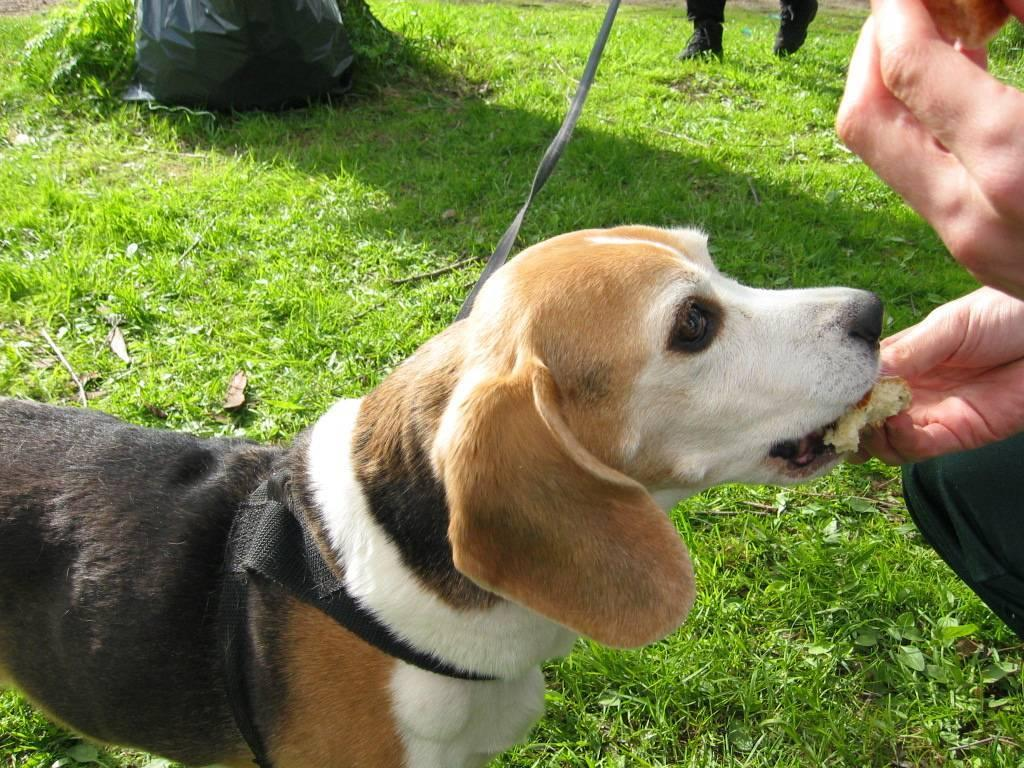How many people are in the image? There are two persons in the image. What is the dog doing in the image? The dog is being fed food by one of the persons. What type of surface is visible in the image? There is grass in the image. What color is the cover in the background of the image? The cover in the background of the image is black. What type of paper is the dog using to write its name in the image? There is no paper or writing activity involving the dog in the image. What substance is the elbow made of in the image? There is no mention of an elbow or any substance related to it in the image. 